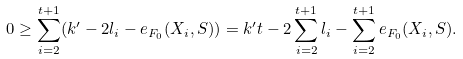Convert formula to latex. <formula><loc_0><loc_0><loc_500><loc_500>0 \geq \sum _ { i = 2 } ^ { t + 1 } ( k ^ { \prime } - 2 l _ { i } - e _ { F _ { 0 } } ( X _ { i } , S ) ) = k ^ { \prime } t - 2 \sum _ { i = 2 } ^ { t + 1 } l _ { i } - \sum _ { i = 2 } ^ { t + 1 } e _ { F _ { 0 } } ( X _ { i } , S ) .</formula> 